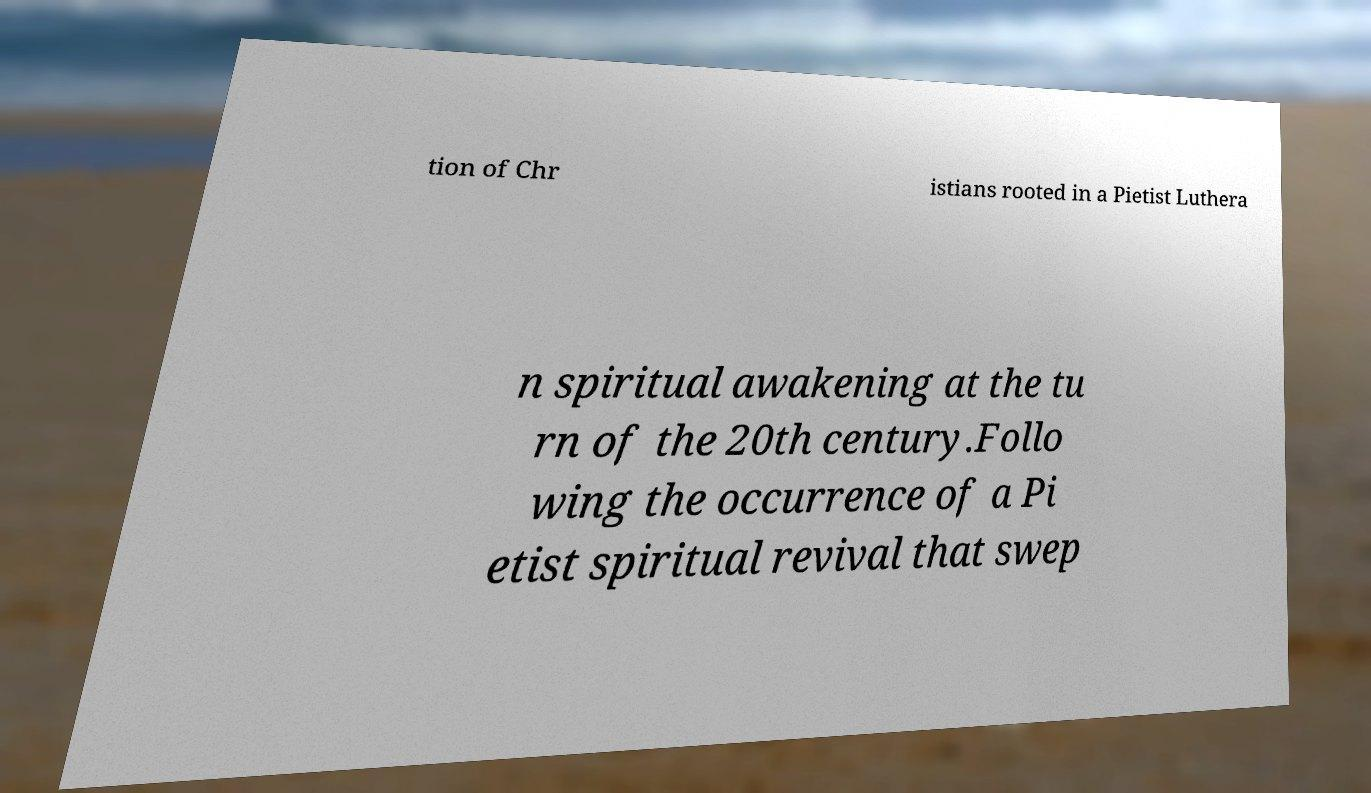Can you read and provide the text displayed in the image?This photo seems to have some interesting text. Can you extract and type it out for me? tion of Chr istians rooted in a Pietist Luthera n spiritual awakening at the tu rn of the 20th century.Follo wing the occurrence of a Pi etist spiritual revival that swep 